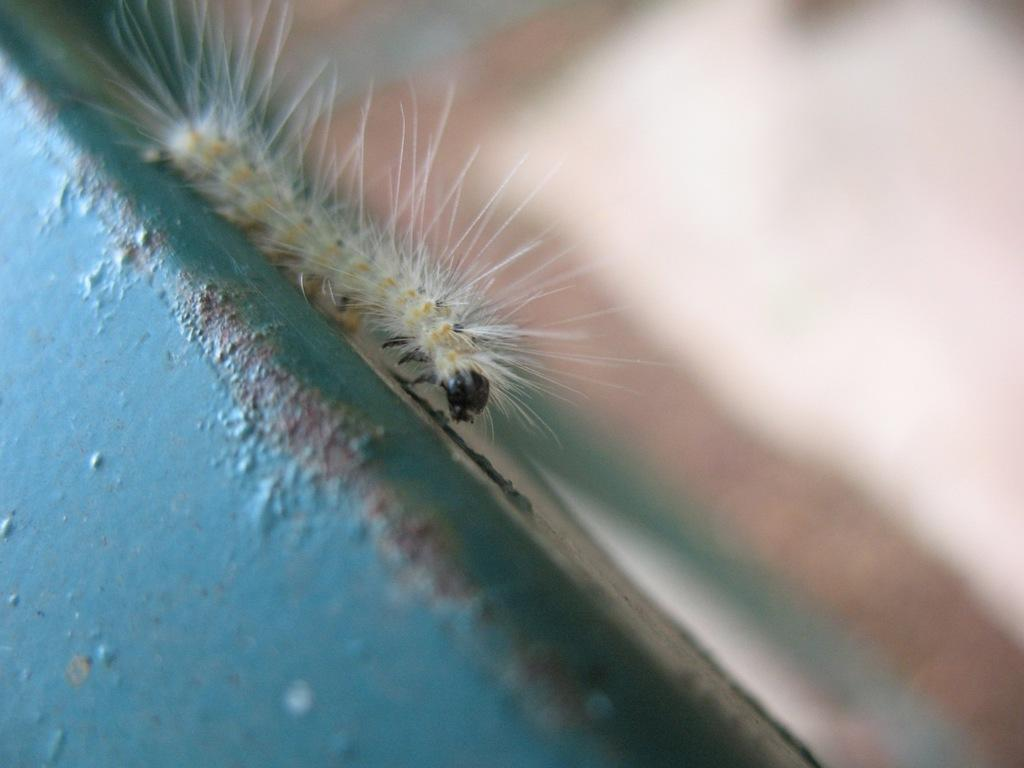What type of creature can be seen in the image? There is an insect in the image. What is the background or surface behind the insect? The insect is on a blue wall. What type of wood is visible along the border of the image? There is no wood or border present in the image; it only features an insect on a blue wall. 